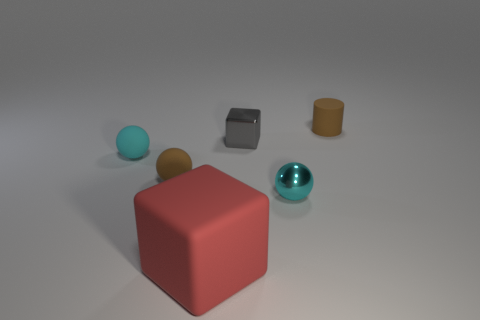Are the brown thing in front of the tiny cyan rubber thing and the large red object made of the same material?
Give a very brief answer. Yes. There is a small brown rubber object that is in front of the brown matte thing that is right of the red rubber block; how many tiny brown matte objects are right of it?
Keep it short and to the point. 1. What size is the gray object?
Make the answer very short. Small. What size is the brown rubber object in front of the brown matte cylinder?
Give a very brief answer. Small. Is the color of the tiny ball that is on the right side of the large object the same as the matte object on the left side of the brown matte ball?
Give a very brief answer. Yes. What number of other things are the same shape as the large thing?
Offer a terse response. 1. Are there an equal number of gray objects in front of the small brown sphere and brown cylinders that are in front of the cyan rubber object?
Offer a terse response. Yes. Is the small brown thing to the left of the small cylinder made of the same material as the small cyan ball on the right side of the large red rubber object?
Provide a succinct answer. No. What number of other objects are the same size as the gray metallic block?
Offer a very short reply. 4. What number of objects are red rubber things or brown things right of the brown ball?
Keep it short and to the point. 2. 